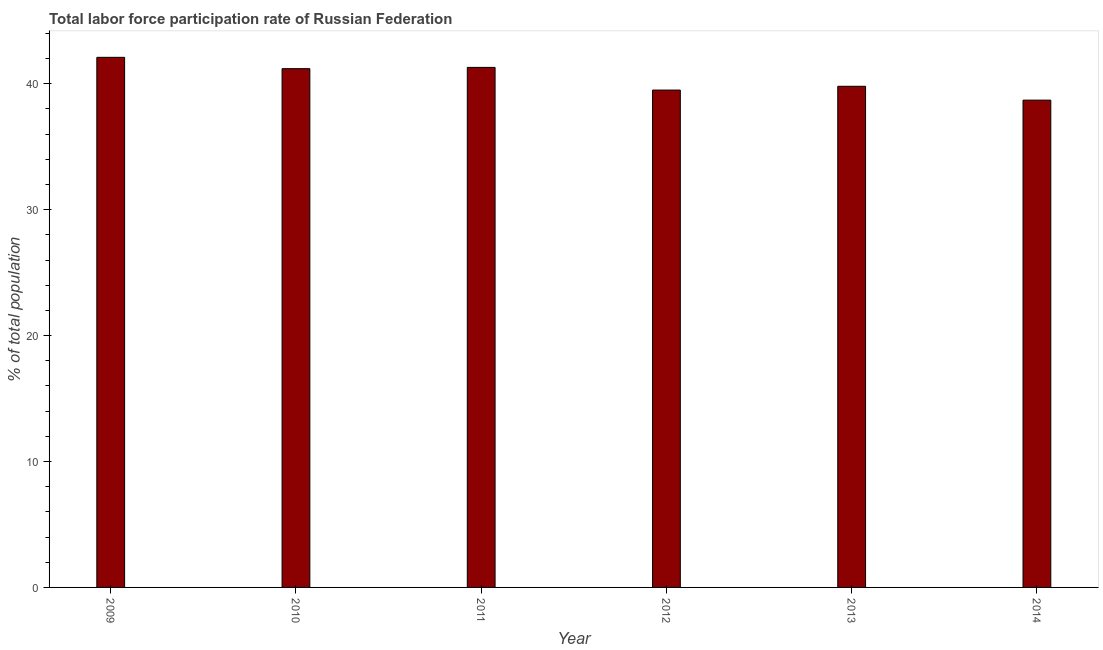Does the graph contain grids?
Ensure brevity in your answer.  No. What is the title of the graph?
Your answer should be very brief. Total labor force participation rate of Russian Federation. What is the label or title of the X-axis?
Your answer should be compact. Year. What is the label or title of the Y-axis?
Ensure brevity in your answer.  % of total population. What is the total labor force participation rate in 2009?
Offer a terse response. 42.1. Across all years, what is the maximum total labor force participation rate?
Ensure brevity in your answer.  42.1. Across all years, what is the minimum total labor force participation rate?
Ensure brevity in your answer.  38.7. In which year was the total labor force participation rate minimum?
Your response must be concise. 2014. What is the sum of the total labor force participation rate?
Make the answer very short. 242.6. What is the average total labor force participation rate per year?
Your response must be concise. 40.43. What is the median total labor force participation rate?
Offer a very short reply. 40.5. What is the ratio of the total labor force participation rate in 2009 to that in 2012?
Provide a succinct answer. 1.07. Is the total labor force participation rate in 2011 less than that in 2012?
Offer a terse response. No. How many bars are there?
Make the answer very short. 6. How many years are there in the graph?
Provide a short and direct response. 6. What is the % of total population of 2009?
Your answer should be very brief. 42.1. What is the % of total population of 2010?
Make the answer very short. 41.2. What is the % of total population in 2011?
Give a very brief answer. 41.3. What is the % of total population in 2012?
Provide a succinct answer. 39.5. What is the % of total population in 2013?
Provide a succinct answer. 39.8. What is the % of total population of 2014?
Keep it short and to the point. 38.7. What is the difference between the % of total population in 2009 and 2014?
Keep it short and to the point. 3.4. What is the difference between the % of total population in 2010 and 2011?
Offer a terse response. -0.1. What is the difference between the % of total population in 2010 and 2012?
Offer a terse response. 1.7. What is the difference between the % of total population in 2010 and 2013?
Your answer should be very brief. 1.4. What is the difference between the % of total population in 2012 and 2013?
Your answer should be compact. -0.3. What is the difference between the % of total population in 2013 and 2014?
Provide a short and direct response. 1.1. What is the ratio of the % of total population in 2009 to that in 2011?
Offer a very short reply. 1.02. What is the ratio of the % of total population in 2009 to that in 2012?
Keep it short and to the point. 1.07. What is the ratio of the % of total population in 2009 to that in 2013?
Provide a succinct answer. 1.06. What is the ratio of the % of total population in 2009 to that in 2014?
Offer a very short reply. 1.09. What is the ratio of the % of total population in 2010 to that in 2011?
Your answer should be compact. 1. What is the ratio of the % of total population in 2010 to that in 2012?
Provide a succinct answer. 1.04. What is the ratio of the % of total population in 2010 to that in 2013?
Provide a short and direct response. 1.03. What is the ratio of the % of total population in 2010 to that in 2014?
Make the answer very short. 1.06. What is the ratio of the % of total population in 2011 to that in 2012?
Offer a terse response. 1.05. What is the ratio of the % of total population in 2011 to that in 2013?
Offer a terse response. 1.04. What is the ratio of the % of total population in 2011 to that in 2014?
Your answer should be compact. 1.07. What is the ratio of the % of total population in 2012 to that in 2014?
Provide a succinct answer. 1.02. What is the ratio of the % of total population in 2013 to that in 2014?
Provide a succinct answer. 1.03. 